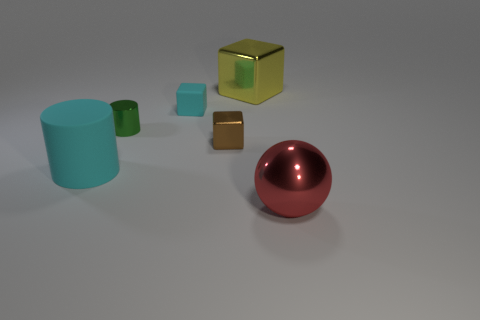Are there more brown metal objects than blue cubes?
Offer a very short reply. Yes. How many objects are shiny objects that are on the right side of the small rubber object or yellow matte blocks?
Offer a very short reply. 3. Are there any metallic objects of the same size as the green cylinder?
Make the answer very short. Yes. Is the number of tiny cyan matte cubes less than the number of tiny green matte objects?
Your response must be concise. No. What number of blocks are yellow shiny things or brown metallic objects?
Make the answer very short. 2. How many other small rubber cubes have the same color as the tiny rubber cube?
Give a very brief answer. 0. How big is the thing that is right of the brown thing and behind the brown block?
Make the answer very short. Large. Are there fewer large yellow metal objects that are in front of the green object than small cyan objects?
Ensure brevity in your answer.  Yes. Is the tiny cyan cube made of the same material as the yellow thing?
Keep it short and to the point. No. What number of objects are either rubber balls or cyan rubber cylinders?
Offer a terse response. 1. 